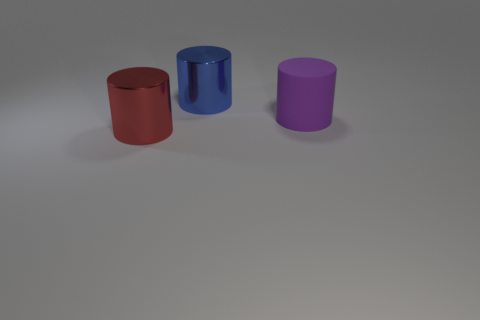Subtract all big metal cylinders. How many cylinders are left? 1 Add 2 metallic spheres. How many objects exist? 5 Subtract 0 brown cubes. How many objects are left? 3 Subtract all big metal things. Subtract all purple cylinders. How many objects are left? 0 Add 3 big red shiny things. How many big red shiny things are left? 4 Add 3 purple metallic blocks. How many purple metallic blocks exist? 3 